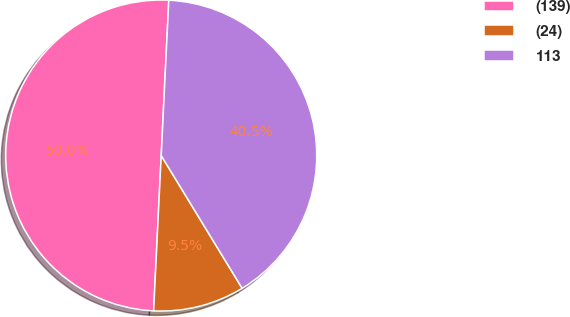Convert chart. <chart><loc_0><loc_0><loc_500><loc_500><pie_chart><fcel>(139)<fcel>(24)<fcel>113<nl><fcel>50.0%<fcel>9.49%<fcel>40.51%<nl></chart> 